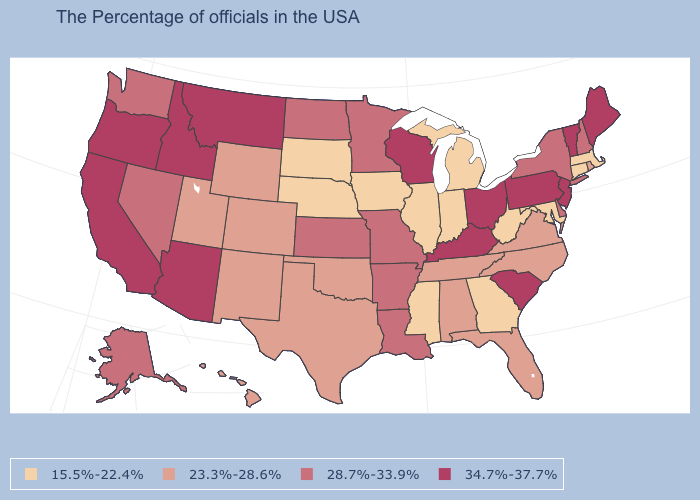What is the value of Minnesota?
Keep it brief. 28.7%-33.9%. Which states hav the highest value in the West?
Quick response, please. Montana, Arizona, Idaho, California, Oregon. What is the value of Vermont?
Concise answer only. 34.7%-37.7%. What is the value of Louisiana?
Quick response, please. 28.7%-33.9%. Does North Carolina have the lowest value in the USA?
Keep it brief. No. What is the lowest value in states that border Vermont?
Short answer required. 15.5%-22.4%. What is the value of Virginia?
Give a very brief answer. 23.3%-28.6%. Name the states that have a value in the range 15.5%-22.4%?
Be succinct. Massachusetts, Connecticut, Maryland, West Virginia, Georgia, Michigan, Indiana, Illinois, Mississippi, Iowa, Nebraska, South Dakota. What is the highest value in states that border Ohio?
Quick response, please. 34.7%-37.7%. What is the highest value in states that border North Carolina?
Keep it brief. 34.7%-37.7%. What is the value of Vermont?
Keep it brief. 34.7%-37.7%. What is the value of Indiana?
Write a very short answer. 15.5%-22.4%. Which states hav the highest value in the South?
Keep it brief. South Carolina, Kentucky. Does Massachusetts have the same value as Michigan?
Give a very brief answer. Yes. What is the value of North Carolina?
Give a very brief answer. 23.3%-28.6%. 